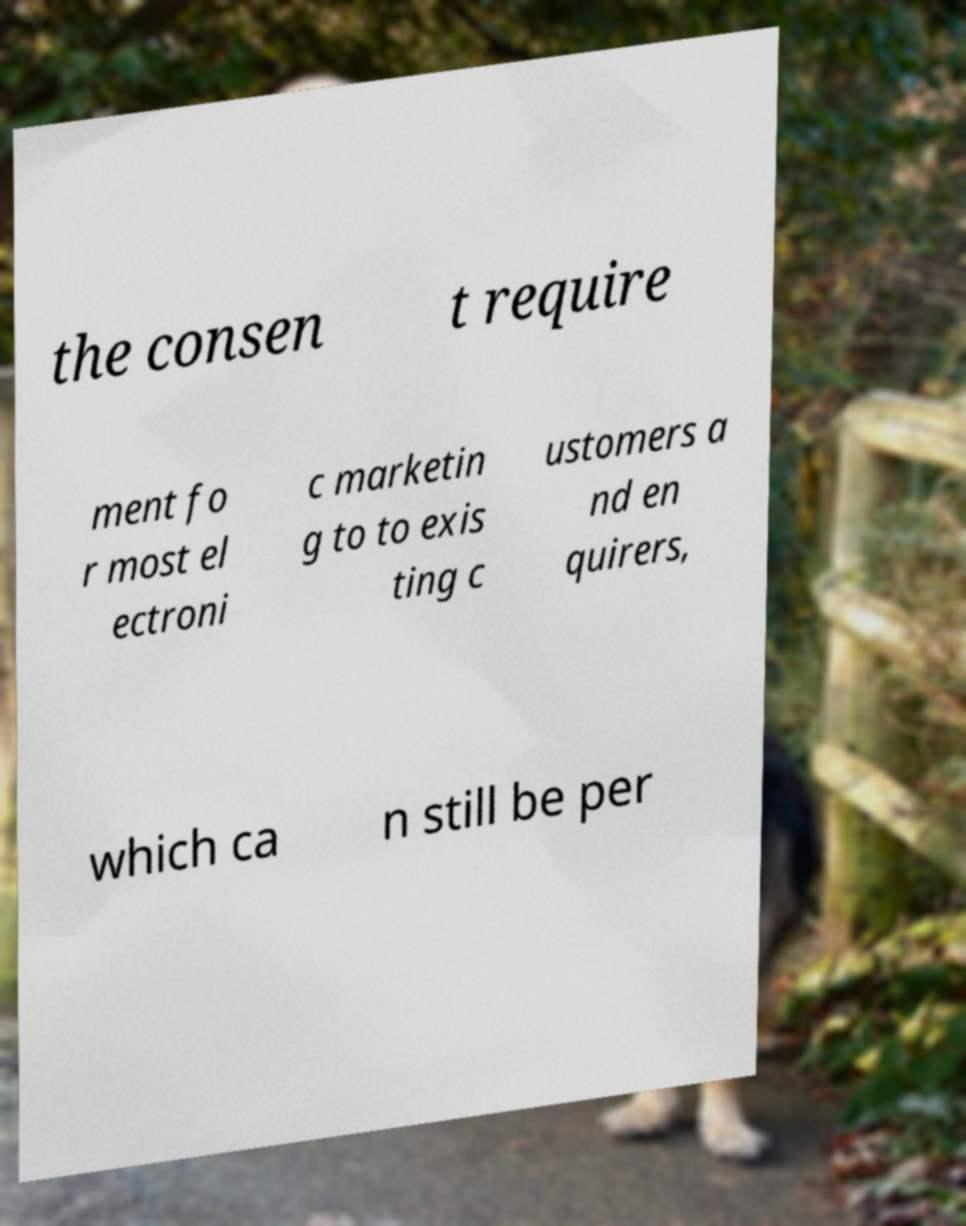I need the written content from this picture converted into text. Can you do that? the consen t require ment fo r most el ectroni c marketin g to to exis ting c ustomers a nd en quirers, which ca n still be per 